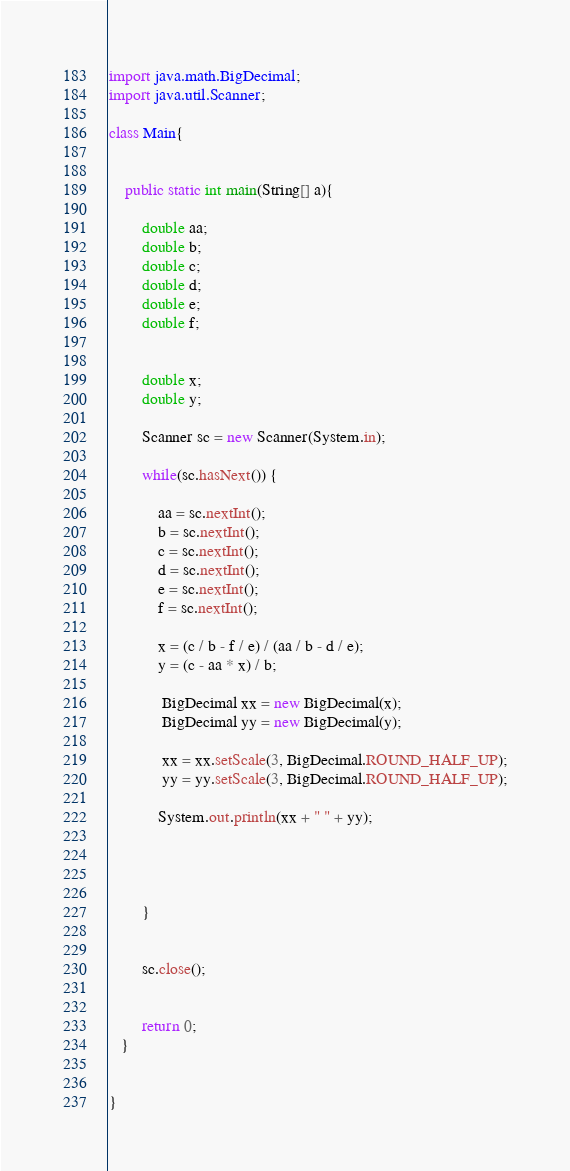Convert code to text. <code><loc_0><loc_0><loc_500><loc_500><_Java_>import java.math.BigDecimal;
import java.util.Scanner;

class Main{


    public static int main(String[] a){

    	double aa;
    	double b;
    	double c;
    	double d;
    	double e;
    	double f;


    	double x;
    	double y;

    	Scanner sc = new Scanner(System.in);

        while(sc.hasNext()) {

        	aa = sc.nextInt();
        	b = sc.nextInt();
        	c = sc.nextInt();
        	d = sc.nextInt();
        	e = sc.nextInt();
        	f = sc.nextInt();

         	x = (c / b - f / e) / (aa / b - d / e);
    		y = (c - aa * x) / b;

    		 BigDecimal xx = new BigDecimal(x);
    		 BigDecimal yy = new BigDecimal(y);

    		 xx = xx.setScale(3, BigDecimal.ROUND_HALF_UP);
    		 yy = yy.setScale(3, BigDecimal.ROUND_HALF_UP);

        	System.out.println(xx + " " + yy);




        }


        sc.close();


        return 0;
   }


}</code> 